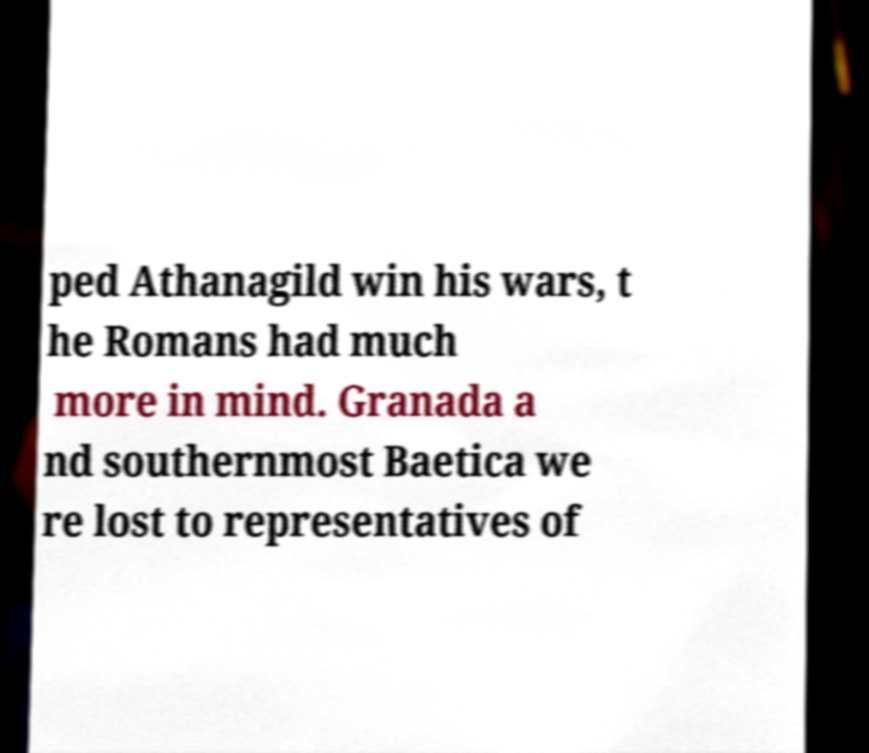Please identify and transcribe the text found in this image. ped Athanagild win his wars, t he Romans had much more in mind. Granada a nd southernmost Baetica we re lost to representatives of 